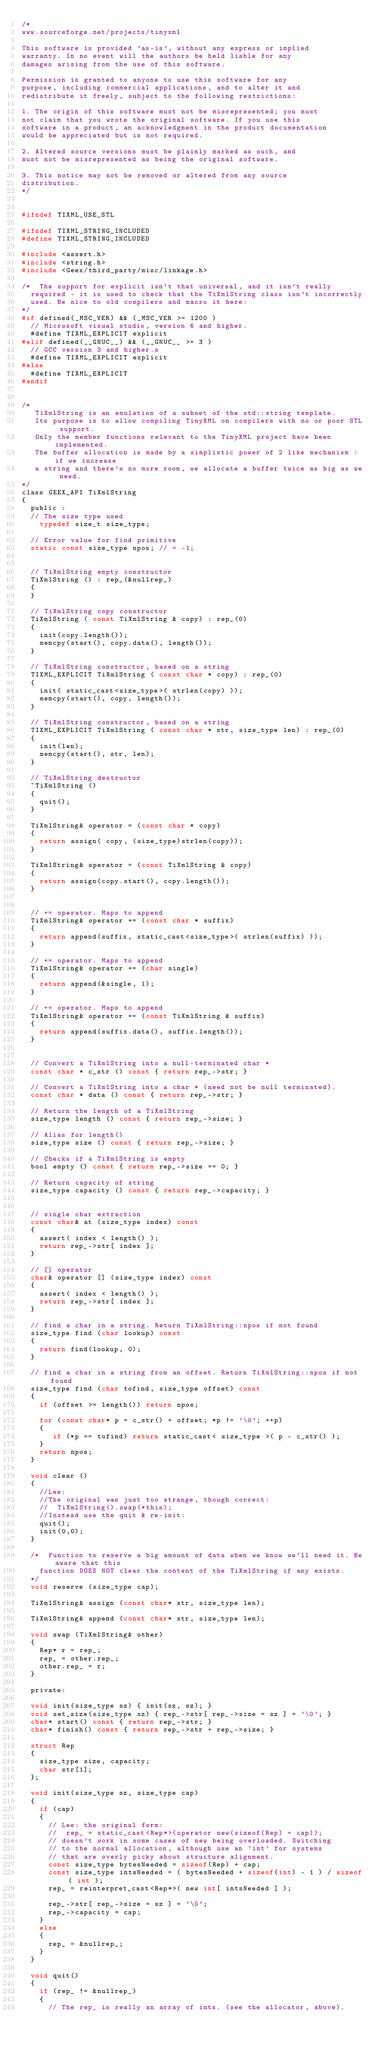Convert code to text. <code><loc_0><loc_0><loc_500><loc_500><_C_>/*
www.sourceforge.net/projects/tinyxml

This software is provided 'as-is', without any express or implied
warranty. In no event will the authors be held liable for any
damages arising from the use of this software.

Permission is granted to anyone to use this software for any
purpose, including commercial applications, and to alter it and
redistribute it freely, subject to the following restrictions:

1. The origin of this software must not be misrepresented; you must
not claim that you wrote the original software. If you use this
software in a product, an acknowledgment in the product documentation
would be appreciated but is not required.

2. Altered source versions must be plainly marked as such, and
must not be misrepresented as being the original software.

3. This notice may not be removed or altered from any source
distribution.
*/


#ifndef TIXML_USE_STL

#ifndef TIXML_STRING_INCLUDED
#define TIXML_STRING_INCLUDED

#include <assert.h>
#include <string.h>
#include <Geex/third_party/misc/linkage.h>

/*	The support for explicit isn't that universal, and it isn't really
	required - it is used to check that the TiXmlString class isn't incorrectly
	used. Be nice to old compilers and macro it here:
*/
#if defined(_MSC_VER) && (_MSC_VER >= 1200 )
	// Microsoft visual studio, version 6 and higher.
	#define TIXML_EXPLICIT explicit
#elif defined(__GNUC__) && (__GNUC__ >= 3 )
	// GCC version 3 and higher.s
	#define TIXML_EXPLICIT explicit
#else
	#define TIXML_EXPLICIT
#endif


/*
   TiXmlString is an emulation of a subset of the std::string template.
   Its purpose is to allow compiling TinyXML on compilers with no or poor STL support.
   Only the member functions relevant to the TinyXML project have been implemented.
   The buffer allocation is made by a simplistic power of 2 like mechanism : if we increase
   a string and there's no more room, we allocate a buffer twice as big as we need.
*/
class GEEX_API TiXmlString
{
  public :
	// The size type used
  	typedef size_t size_type;

	// Error value for find primitive
	static const size_type npos; // = -1;


	// TiXmlString empty constructor
	TiXmlString () : rep_(&nullrep_)
	{
	}

	// TiXmlString copy constructor
	TiXmlString ( const TiXmlString & copy) : rep_(0)
	{
		init(copy.length());
		memcpy(start(), copy.data(), length());
	}

	// TiXmlString constructor, based on a string
	TIXML_EXPLICIT TiXmlString ( const char * copy) : rep_(0)
	{
		init( static_cast<size_type>( strlen(copy) ));
		memcpy(start(), copy, length());
	}

	// TiXmlString constructor, based on a string
	TIXML_EXPLICIT TiXmlString ( const char * str, size_type len) : rep_(0)
	{
		init(len);
		memcpy(start(), str, len);
	}

	// TiXmlString destructor
	~TiXmlString ()
	{
		quit();
	}

	TiXmlString& operator = (const char * copy)
	{
		return assign( copy, (size_type)strlen(copy));
	}

	TiXmlString& operator = (const TiXmlString & copy)
	{
		return assign(copy.start(), copy.length());
	}


	// += operator. Maps to append
	TiXmlString& operator += (const char * suffix)
	{
		return append(suffix, static_cast<size_type>( strlen(suffix) ));
	}

	// += operator. Maps to append
	TiXmlString& operator += (char single)
	{
		return append(&single, 1);
	}

	// += operator. Maps to append
	TiXmlString& operator += (const TiXmlString & suffix)
	{
		return append(suffix.data(), suffix.length());
	}


	// Convert a TiXmlString into a null-terminated char *
	const char * c_str () const { return rep_->str; }

	// Convert a TiXmlString into a char * (need not be null terminated).
	const char * data () const { return rep_->str; }

	// Return the length of a TiXmlString
	size_type length () const { return rep_->size; }

	// Alias for length()
	size_type size () const { return rep_->size; }

	// Checks if a TiXmlString is empty
	bool empty () const { return rep_->size == 0; }

	// Return capacity of string
	size_type capacity () const { return rep_->capacity; }


	// single char extraction
	const char& at (size_type index) const
	{
		assert( index < length() );
		return rep_->str[ index ];
	}

	// [] operator
	char& operator [] (size_type index) const
	{
		assert( index < length() );
		return rep_->str[ index ];
	}

	// find a char in a string. Return TiXmlString::npos if not found
	size_type find (char lookup) const
	{
		return find(lookup, 0);
	}

	// find a char in a string from an offset. Return TiXmlString::npos if not found
	size_type find (char tofind, size_type offset) const
	{
		if (offset >= length()) return npos;

		for (const char* p = c_str() + offset; *p != '\0'; ++p)
		{
		   if (*p == tofind) return static_cast< size_type >( p - c_str() );
		}
		return npos;
	}

	void clear ()
	{
		//Lee:
		//The original was just too strange, though correct:
		//	TiXmlString().swap(*this);
		//Instead use the quit & re-init:
		quit();
		init(0,0);
	}

	/*	Function to reserve a big amount of data when we know we'll need it. Be aware that this
		function DOES NOT clear the content of the TiXmlString if any exists.
	*/
	void reserve (size_type cap);

	TiXmlString& assign (const char* str, size_type len);

	TiXmlString& append (const char* str, size_type len);

	void swap (TiXmlString& other)
	{
		Rep* r = rep_;
		rep_ = other.rep_;
		other.rep_ = r;
	}

  private:

	void init(size_type sz) { init(sz, sz); }
	void set_size(size_type sz) { rep_->str[ rep_->size = sz ] = '\0'; }
	char* start() const { return rep_->str; }
	char* finish() const { return rep_->str + rep_->size; }

	struct Rep
	{
		size_type size, capacity;
		char str[1];
	};

	void init(size_type sz, size_type cap)
	{
		if (cap)
		{
			// Lee: the original form:
			//	rep_ = static_cast<Rep*>(operator new(sizeof(Rep) + cap));
			// doesn't work in some cases of new being overloaded. Switching
			// to the normal allocation, although use an 'int' for systems
			// that are overly picky about structure alignment.
			const size_type bytesNeeded = sizeof(Rep) + cap;
			const size_type intsNeeded = ( bytesNeeded + sizeof(int) - 1 ) / sizeof( int ); 
			rep_ = reinterpret_cast<Rep*>( new int[ intsNeeded ] );

			rep_->str[ rep_->size = sz ] = '\0';
			rep_->capacity = cap;
		}
		else
		{
			rep_ = &nullrep_;
		}
	}

	void quit()
	{
		if (rep_ != &nullrep_)
		{
			// The rep_ is really an array of ints. (see the allocator, above).</code> 